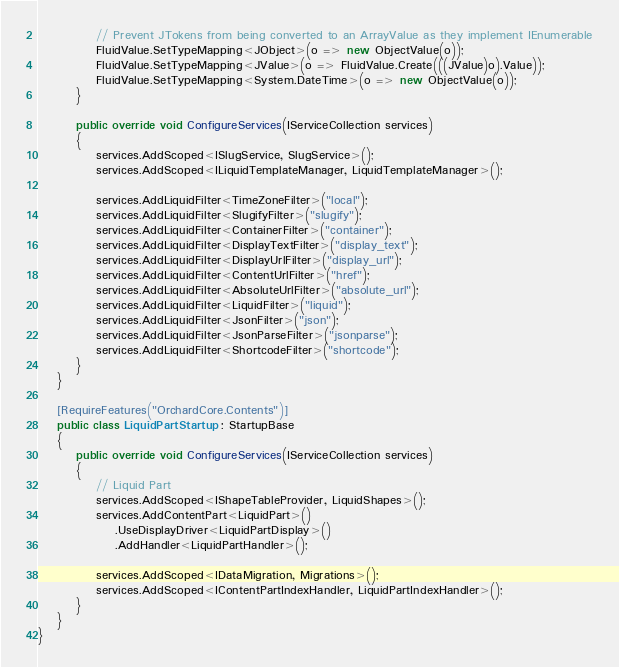Convert code to text. <code><loc_0><loc_0><loc_500><loc_500><_C#_>
            // Prevent JTokens from being converted to an ArrayValue as they implement IEnumerable
            FluidValue.SetTypeMapping<JObject>(o => new ObjectValue(o));
            FluidValue.SetTypeMapping<JValue>(o => FluidValue.Create(((JValue)o).Value));
            FluidValue.SetTypeMapping<System.DateTime>(o => new ObjectValue(o));
        }

        public override void ConfigureServices(IServiceCollection services)
        {
            services.AddScoped<ISlugService, SlugService>();
            services.AddScoped<ILiquidTemplateManager, LiquidTemplateManager>();

            services.AddLiquidFilter<TimeZoneFilter>("local");
            services.AddLiquidFilter<SlugifyFilter>("slugify");
            services.AddLiquidFilter<ContainerFilter>("container");
            services.AddLiquidFilter<DisplayTextFilter>("display_text");
            services.AddLiquidFilter<DisplayUrlFilter>("display_url");
            services.AddLiquidFilter<ContentUrlFilter>("href");
            services.AddLiquidFilter<AbsoluteUrlFilter>("absolute_url");
            services.AddLiquidFilter<LiquidFilter>("liquid");
            services.AddLiquidFilter<JsonFilter>("json");
            services.AddLiquidFilter<JsonParseFilter>("jsonparse");
            services.AddLiquidFilter<ShortcodeFilter>("shortcode");
        }
    }

    [RequireFeatures("OrchardCore.Contents")]
    public class LiquidPartStartup : StartupBase
    {
        public override void ConfigureServices(IServiceCollection services)
        {
            // Liquid Part
            services.AddScoped<IShapeTableProvider, LiquidShapes>();
            services.AddContentPart<LiquidPart>()
                .UseDisplayDriver<LiquidPartDisplay>()
                .AddHandler<LiquidPartHandler>();

            services.AddScoped<IDataMigration, Migrations>();
            services.AddScoped<IContentPartIndexHandler, LiquidPartIndexHandler>();
        }
    }
}
</code> 